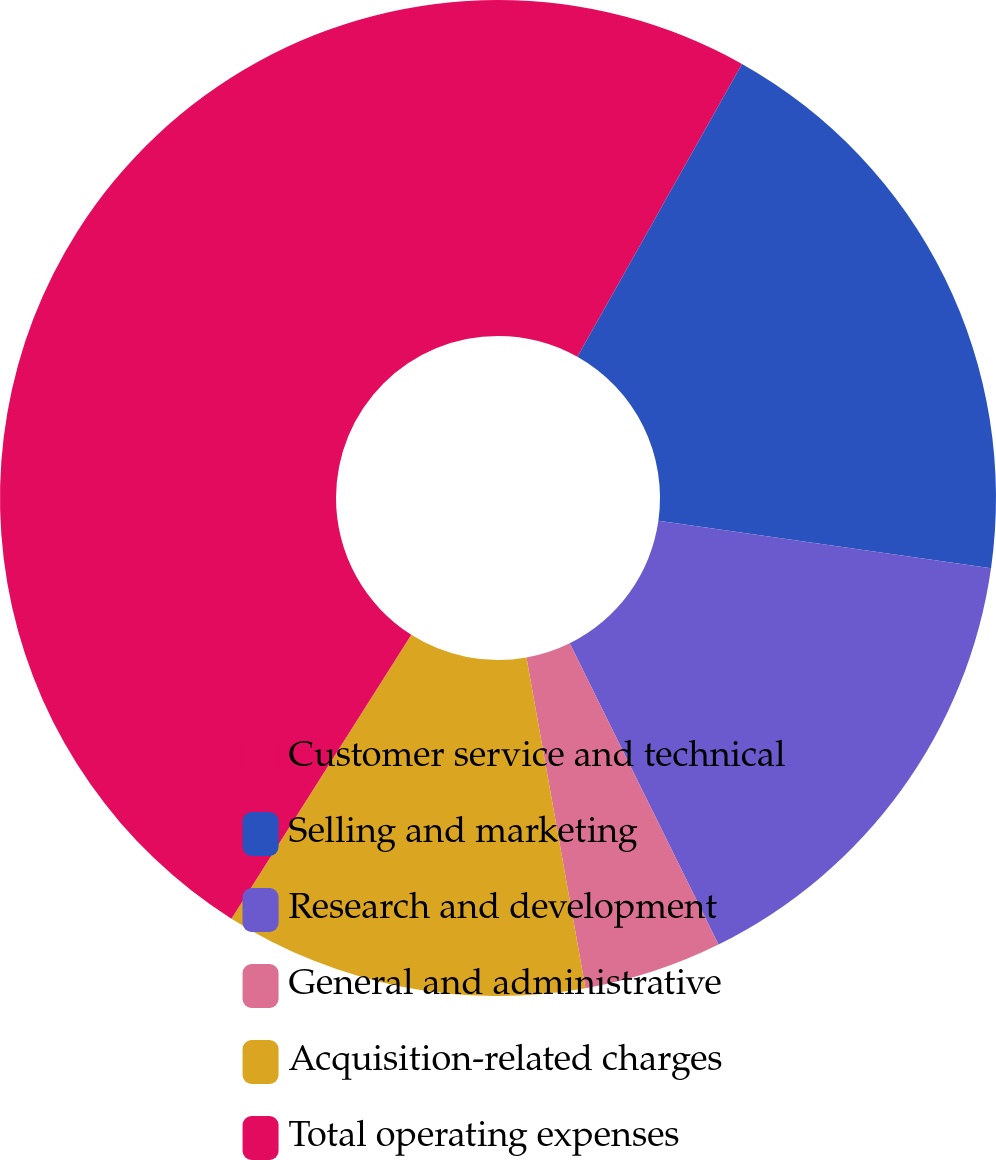<chart> <loc_0><loc_0><loc_500><loc_500><pie_chart><fcel>Customer service and technical<fcel>Selling and marketing<fcel>Research and development<fcel>General and administrative<fcel>Acquisition-related charges<fcel>Total operating expenses<nl><fcel>8.15%<fcel>19.1%<fcel>15.45%<fcel>4.49%<fcel>11.8%<fcel>41.01%<nl></chart> 